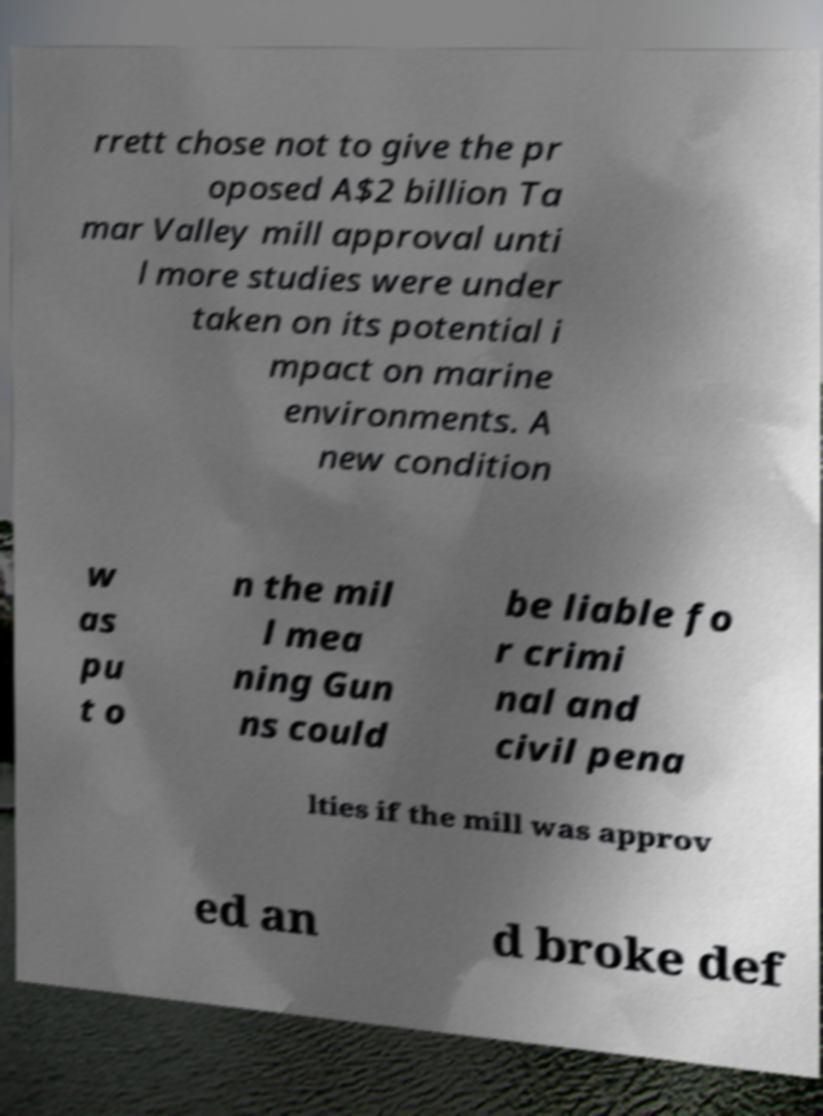For documentation purposes, I need the text within this image transcribed. Could you provide that? rrett chose not to give the pr oposed A$2 billion Ta mar Valley mill approval unti l more studies were under taken on its potential i mpact on marine environments. A new condition w as pu t o n the mil l mea ning Gun ns could be liable fo r crimi nal and civil pena lties if the mill was approv ed an d broke def 